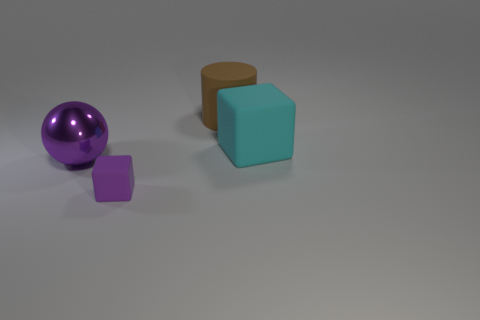Is there any other thing that is the same shape as the brown rubber thing?
Make the answer very short. No. What is the color of the other big thing that is made of the same material as the big brown object?
Provide a short and direct response. Cyan. What number of small matte objects are the same color as the big sphere?
Provide a short and direct response. 1. There is a small cube that is the same color as the sphere; what is it made of?
Give a very brief answer. Rubber. There is a purple thing behind the matte block to the left of the brown rubber cylinder; what is it made of?
Offer a terse response. Metal. Is there a purple thing that has the same material as the large cube?
Offer a very short reply. Yes. What material is the purple object that is the same size as the brown matte object?
Keep it short and to the point. Metal. There is a rubber object that is behind the cube to the right of the rubber thing that is in front of the ball; what is its size?
Ensure brevity in your answer.  Large. There is a cube on the right side of the purple rubber block; are there any tiny matte cubes that are in front of it?
Give a very brief answer. Yes. Does the small purple thing have the same shape as the rubber object right of the brown rubber cylinder?
Keep it short and to the point. Yes. 